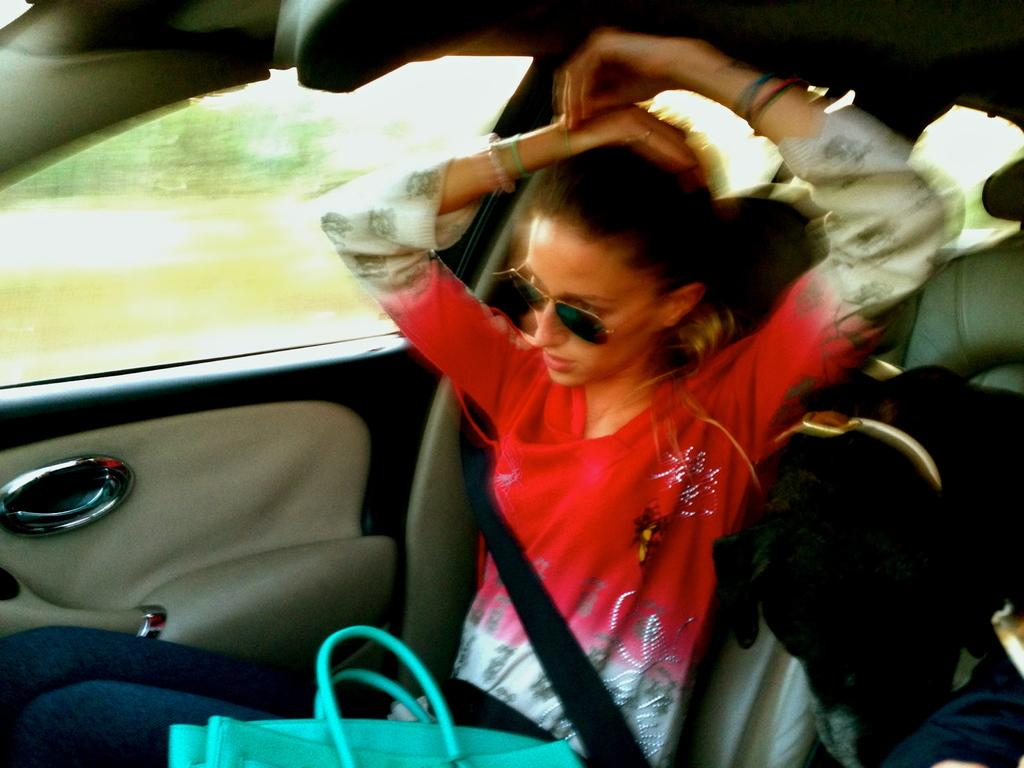Who is present in the image? There is a woman in the image. What other living creature is present in the image? There is a dog in the image. Where are the woman and the dog located? Both the woman and the dog are inside a vehicle. What object can be seen in the image? There is a bag in the image. How many books can be seen on the dog's head in the image? There are no books present in the image, and therefore none can be seen on the dog's head. 